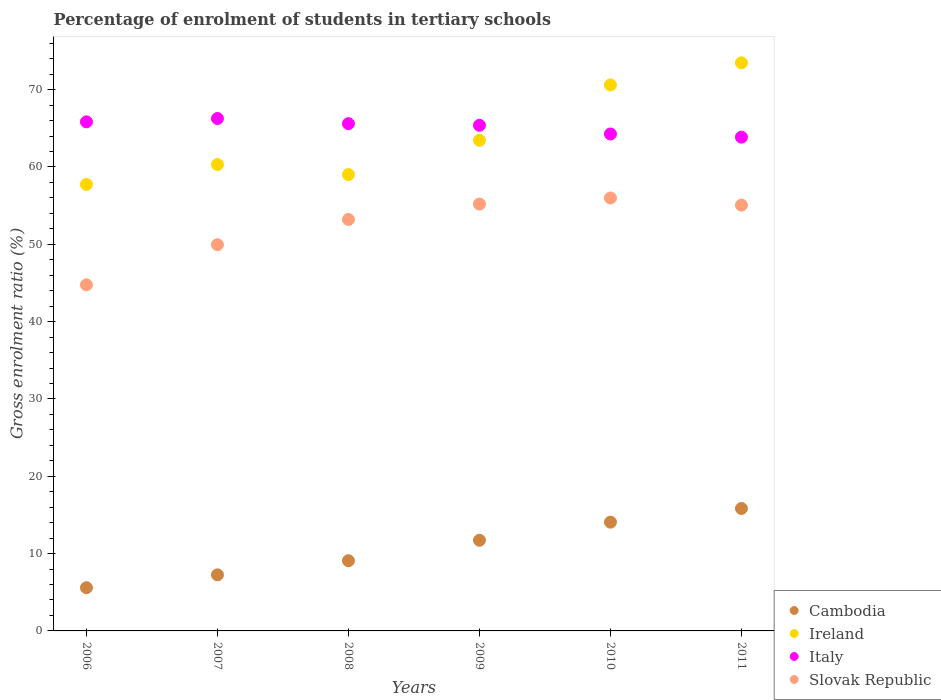What is the percentage of students enrolled in tertiary schools in Slovak Republic in 2008?
Offer a very short reply. 53.22. Across all years, what is the maximum percentage of students enrolled in tertiary schools in Ireland?
Your answer should be very brief. 73.47. Across all years, what is the minimum percentage of students enrolled in tertiary schools in Cambodia?
Provide a succinct answer. 5.59. In which year was the percentage of students enrolled in tertiary schools in Cambodia maximum?
Provide a short and direct response. 2011. What is the total percentage of students enrolled in tertiary schools in Italy in the graph?
Give a very brief answer. 391.22. What is the difference between the percentage of students enrolled in tertiary schools in Slovak Republic in 2007 and that in 2008?
Offer a very short reply. -3.27. What is the difference between the percentage of students enrolled in tertiary schools in Italy in 2008 and the percentage of students enrolled in tertiary schools in Slovak Republic in 2010?
Your response must be concise. 9.61. What is the average percentage of students enrolled in tertiary schools in Italy per year?
Make the answer very short. 65.2. In the year 2011, what is the difference between the percentage of students enrolled in tertiary schools in Cambodia and percentage of students enrolled in tertiary schools in Ireland?
Offer a terse response. -57.64. What is the ratio of the percentage of students enrolled in tertiary schools in Cambodia in 2007 to that in 2009?
Provide a succinct answer. 0.62. Is the percentage of students enrolled in tertiary schools in Slovak Republic in 2008 less than that in 2010?
Ensure brevity in your answer.  Yes. Is the difference between the percentage of students enrolled in tertiary schools in Cambodia in 2009 and 2011 greater than the difference between the percentage of students enrolled in tertiary schools in Ireland in 2009 and 2011?
Make the answer very short. Yes. What is the difference between the highest and the second highest percentage of students enrolled in tertiary schools in Slovak Republic?
Provide a succinct answer. 0.78. What is the difference between the highest and the lowest percentage of students enrolled in tertiary schools in Cambodia?
Provide a short and direct response. 10.24. In how many years, is the percentage of students enrolled in tertiary schools in Ireland greater than the average percentage of students enrolled in tertiary schools in Ireland taken over all years?
Your answer should be very brief. 2. Is the sum of the percentage of students enrolled in tertiary schools in Slovak Republic in 2008 and 2010 greater than the maximum percentage of students enrolled in tertiary schools in Italy across all years?
Give a very brief answer. Yes. Does the percentage of students enrolled in tertiary schools in Ireland monotonically increase over the years?
Make the answer very short. No. Is the percentage of students enrolled in tertiary schools in Ireland strictly less than the percentage of students enrolled in tertiary schools in Cambodia over the years?
Offer a terse response. No. How many dotlines are there?
Your answer should be compact. 4. How many years are there in the graph?
Offer a very short reply. 6. Are the values on the major ticks of Y-axis written in scientific E-notation?
Offer a terse response. No. What is the title of the graph?
Offer a very short reply. Percentage of enrolment of students in tertiary schools. What is the label or title of the X-axis?
Your response must be concise. Years. What is the label or title of the Y-axis?
Keep it short and to the point. Gross enrolment ratio (%). What is the Gross enrolment ratio (%) in Cambodia in 2006?
Offer a terse response. 5.59. What is the Gross enrolment ratio (%) of Ireland in 2006?
Provide a short and direct response. 57.75. What is the Gross enrolment ratio (%) of Italy in 2006?
Your answer should be very brief. 65.84. What is the Gross enrolment ratio (%) in Slovak Republic in 2006?
Offer a very short reply. 44.76. What is the Gross enrolment ratio (%) of Cambodia in 2007?
Ensure brevity in your answer.  7.25. What is the Gross enrolment ratio (%) in Ireland in 2007?
Offer a very short reply. 60.32. What is the Gross enrolment ratio (%) in Italy in 2007?
Keep it short and to the point. 66.27. What is the Gross enrolment ratio (%) in Slovak Republic in 2007?
Offer a very short reply. 49.95. What is the Gross enrolment ratio (%) of Cambodia in 2008?
Offer a terse response. 9.08. What is the Gross enrolment ratio (%) of Ireland in 2008?
Your answer should be compact. 59.02. What is the Gross enrolment ratio (%) in Italy in 2008?
Ensure brevity in your answer.  65.6. What is the Gross enrolment ratio (%) of Slovak Republic in 2008?
Provide a short and direct response. 53.22. What is the Gross enrolment ratio (%) of Cambodia in 2009?
Your answer should be compact. 11.72. What is the Gross enrolment ratio (%) in Ireland in 2009?
Ensure brevity in your answer.  63.45. What is the Gross enrolment ratio (%) in Italy in 2009?
Your answer should be compact. 65.39. What is the Gross enrolment ratio (%) in Slovak Republic in 2009?
Your response must be concise. 55.21. What is the Gross enrolment ratio (%) in Cambodia in 2010?
Offer a very short reply. 14.07. What is the Gross enrolment ratio (%) of Ireland in 2010?
Provide a succinct answer. 70.61. What is the Gross enrolment ratio (%) of Italy in 2010?
Offer a terse response. 64.27. What is the Gross enrolment ratio (%) in Slovak Republic in 2010?
Keep it short and to the point. 55.99. What is the Gross enrolment ratio (%) in Cambodia in 2011?
Offer a terse response. 15.83. What is the Gross enrolment ratio (%) in Ireland in 2011?
Offer a very short reply. 73.47. What is the Gross enrolment ratio (%) of Italy in 2011?
Make the answer very short. 63.86. What is the Gross enrolment ratio (%) in Slovak Republic in 2011?
Your response must be concise. 55.07. Across all years, what is the maximum Gross enrolment ratio (%) of Cambodia?
Make the answer very short. 15.83. Across all years, what is the maximum Gross enrolment ratio (%) of Ireland?
Your response must be concise. 73.47. Across all years, what is the maximum Gross enrolment ratio (%) of Italy?
Give a very brief answer. 66.27. Across all years, what is the maximum Gross enrolment ratio (%) in Slovak Republic?
Keep it short and to the point. 55.99. Across all years, what is the minimum Gross enrolment ratio (%) of Cambodia?
Offer a very short reply. 5.59. Across all years, what is the minimum Gross enrolment ratio (%) of Ireland?
Ensure brevity in your answer.  57.75. Across all years, what is the minimum Gross enrolment ratio (%) in Italy?
Provide a short and direct response. 63.86. Across all years, what is the minimum Gross enrolment ratio (%) of Slovak Republic?
Make the answer very short. 44.76. What is the total Gross enrolment ratio (%) in Cambodia in the graph?
Keep it short and to the point. 63.55. What is the total Gross enrolment ratio (%) of Ireland in the graph?
Your response must be concise. 384.61. What is the total Gross enrolment ratio (%) of Italy in the graph?
Your response must be concise. 391.22. What is the total Gross enrolment ratio (%) of Slovak Republic in the graph?
Keep it short and to the point. 314.19. What is the difference between the Gross enrolment ratio (%) of Cambodia in 2006 and that in 2007?
Ensure brevity in your answer.  -1.66. What is the difference between the Gross enrolment ratio (%) of Ireland in 2006 and that in 2007?
Make the answer very short. -2.58. What is the difference between the Gross enrolment ratio (%) of Italy in 2006 and that in 2007?
Provide a succinct answer. -0.43. What is the difference between the Gross enrolment ratio (%) of Slovak Republic in 2006 and that in 2007?
Make the answer very short. -5.19. What is the difference between the Gross enrolment ratio (%) of Cambodia in 2006 and that in 2008?
Provide a succinct answer. -3.49. What is the difference between the Gross enrolment ratio (%) in Ireland in 2006 and that in 2008?
Keep it short and to the point. -1.27. What is the difference between the Gross enrolment ratio (%) in Italy in 2006 and that in 2008?
Provide a succinct answer. 0.24. What is the difference between the Gross enrolment ratio (%) of Slovak Republic in 2006 and that in 2008?
Your answer should be very brief. -8.46. What is the difference between the Gross enrolment ratio (%) of Cambodia in 2006 and that in 2009?
Provide a short and direct response. -6.13. What is the difference between the Gross enrolment ratio (%) of Ireland in 2006 and that in 2009?
Ensure brevity in your answer.  -5.71. What is the difference between the Gross enrolment ratio (%) of Italy in 2006 and that in 2009?
Keep it short and to the point. 0.45. What is the difference between the Gross enrolment ratio (%) of Slovak Republic in 2006 and that in 2009?
Give a very brief answer. -10.45. What is the difference between the Gross enrolment ratio (%) of Cambodia in 2006 and that in 2010?
Make the answer very short. -8.48. What is the difference between the Gross enrolment ratio (%) in Ireland in 2006 and that in 2010?
Ensure brevity in your answer.  -12.86. What is the difference between the Gross enrolment ratio (%) of Italy in 2006 and that in 2010?
Give a very brief answer. 1.57. What is the difference between the Gross enrolment ratio (%) in Slovak Republic in 2006 and that in 2010?
Offer a terse response. -11.23. What is the difference between the Gross enrolment ratio (%) in Cambodia in 2006 and that in 2011?
Your response must be concise. -10.24. What is the difference between the Gross enrolment ratio (%) of Ireland in 2006 and that in 2011?
Offer a terse response. -15.73. What is the difference between the Gross enrolment ratio (%) in Italy in 2006 and that in 2011?
Keep it short and to the point. 1.98. What is the difference between the Gross enrolment ratio (%) of Slovak Republic in 2006 and that in 2011?
Your answer should be very brief. -10.31. What is the difference between the Gross enrolment ratio (%) of Cambodia in 2007 and that in 2008?
Your answer should be compact. -1.83. What is the difference between the Gross enrolment ratio (%) of Ireland in 2007 and that in 2008?
Provide a short and direct response. 1.3. What is the difference between the Gross enrolment ratio (%) of Italy in 2007 and that in 2008?
Keep it short and to the point. 0.66. What is the difference between the Gross enrolment ratio (%) of Slovak Republic in 2007 and that in 2008?
Offer a very short reply. -3.27. What is the difference between the Gross enrolment ratio (%) in Cambodia in 2007 and that in 2009?
Offer a terse response. -4.47. What is the difference between the Gross enrolment ratio (%) of Ireland in 2007 and that in 2009?
Offer a very short reply. -3.13. What is the difference between the Gross enrolment ratio (%) in Italy in 2007 and that in 2009?
Provide a short and direct response. 0.88. What is the difference between the Gross enrolment ratio (%) of Slovak Republic in 2007 and that in 2009?
Keep it short and to the point. -5.26. What is the difference between the Gross enrolment ratio (%) in Cambodia in 2007 and that in 2010?
Provide a succinct answer. -6.82. What is the difference between the Gross enrolment ratio (%) of Ireland in 2007 and that in 2010?
Make the answer very short. -10.29. What is the difference between the Gross enrolment ratio (%) in Italy in 2007 and that in 2010?
Make the answer very short. 2. What is the difference between the Gross enrolment ratio (%) of Slovak Republic in 2007 and that in 2010?
Offer a terse response. -6.04. What is the difference between the Gross enrolment ratio (%) in Cambodia in 2007 and that in 2011?
Ensure brevity in your answer.  -8.58. What is the difference between the Gross enrolment ratio (%) in Ireland in 2007 and that in 2011?
Offer a very short reply. -13.15. What is the difference between the Gross enrolment ratio (%) of Italy in 2007 and that in 2011?
Your answer should be very brief. 2.41. What is the difference between the Gross enrolment ratio (%) in Slovak Republic in 2007 and that in 2011?
Your answer should be compact. -5.13. What is the difference between the Gross enrolment ratio (%) in Cambodia in 2008 and that in 2009?
Provide a succinct answer. -2.64. What is the difference between the Gross enrolment ratio (%) in Ireland in 2008 and that in 2009?
Ensure brevity in your answer.  -4.43. What is the difference between the Gross enrolment ratio (%) of Italy in 2008 and that in 2009?
Provide a short and direct response. 0.21. What is the difference between the Gross enrolment ratio (%) of Slovak Republic in 2008 and that in 2009?
Provide a short and direct response. -1.99. What is the difference between the Gross enrolment ratio (%) of Cambodia in 2008 and that in 2010?
Give a very brief answer. -4.99. What is the difference between the Gross enrolment ratio (%) in Ireland in 2008 and that in 2010?
Offer a very short reply. -11.59. What is the difference between the Gross enrolment ratio (%) in Italy in 2008 and that in 2010?
Offer a terse response. 1.33. What is the difference between the Gross enrolment ratio (%) in Slovak Republic in 2008 and that in 2010?
Keep it short and to the point. -2.77. What is the difference between the Gross enrolment ratio (%) of Cambodia in 2008 and that in 2011?
Offer a terse response. -6.75. What is the difference between the Gross enrolment ratio (%) in Ireland in 2008 and that in 2011?
Give a very brief answer. -14.45. What is the difference between the Gross enrolment ratio (%) in Italy in 2008 and that in 2011?
Ensure brevity in your answer.  1.74. What is the difference between the Gross enrolment ratio (%) of Slovak Republic in 2008 and that in 2011?
Your response must be concise. -1.85. What is the difference between the Gross enrolment ratio (%) in Cambodia in 2009 and that in 2010?
Your response must be concise. -2.34. What is the difference between the Gross enrolment ratio (%) of Ireland in 2009 and that in 2010?
Make the answer very short. -7.15. What is the difference between the Gross enrolment ratio (%) in Italy in 2009 and that in 2010?
Ensure brevity in your answer.  1.12. What is the difference between the Gross enrolment ratio (%) in Slovak Republic in 2009 and that in 2010?
Offer a terse response. -0.78. What is the difference between the Gross enrolment ratio (%) of Cambodia in 2009 and that in 2011?
Give a very brief answer. -4.11. What is the difference between the Gross enrolment ratio (%) of Ireland in 2009 and that in 2011?
Offer a terse response. -10.02. What is the difference between the Gross enrolment ratio (%) of Italy in 2009 and that in 2011?
Offer a terse response. 1.53. What is the difference between the Gross enrolment ratio (%) in Slovak Republic in 2009 and that in 2011?
Keep it short and to the point. 0.13. What is the difference between the Gross enrolment ratio (%) of Cambodia in 2010 and that in 2011?
Offer a very short reply. -1.77. What is the difference between the Gross enrolment ratio (%) of Ireland in 2010 and that in 2011?
Offer a very short reply. -2.86. What is the difference between the Gross enrolment ratio (%) in Italy in 2010 and that in 2011?
Ensure brevity in your answer.  0.41. What is the difference between the Gross enrolment ratio (%) of Slovak Republic in 2010 and that in 2011?
Give a very brief answer. 0.92. What is the difference between the Gross enrolment ratio (%) in Cambodia in 2006 and the Gross enrolment ratio (%) in Ireland in 2007?
Your answer should be compact. -54.73. What is the difference between the Gross enrolment ratio (%) of Cambodia in 2006 and the Gross enrolment ratio (%) of Italy in 2007?
Provide a succinct answer. -60.67. What is the difference between the Gross enrolment ratio (%) of Cambodia in 2006 and the Gross enrolment ratio (%) of Slovak Republic in 2007?
Provide a succinct answer. -44.35. What is the difference between the Gross enrolment ratio (%) of Ireland in 2006 and the Gross enrolment ratio (%) of Italy in 2007?
Give a very brief answer. -8.52. What is the difference between the Gross enrolment ratio (%) in Ireland in 2006 and the Gross enrolment ratio (%) in Slovak Republic in 2007?
Your answer should be compact. 7.8. What is the difference between the Gross enrolment ratio (%) of Italy in 2006 and the Gross enrolment ratio (%) of Slovak Republic in 2007?
Your answer should be compact. 15.89. What is the difference between the Gross enrolment ratio (%) in Cambodia in 2006 and the Gross enrolment ratio (%) in Ireland in 2008?
Keep it short and to the point. -53.43. What is the difference between the Gross enrolment ratio (%) in Cambodia in 2006 and the Gross enrolment ratio (%) in Italy in 2008?
Your answer should be very brief. -60.01. What is the difference between the Gross enrolment ratio (%) of Cambodia in 2006 and the Gross enrolment ratio (%) of Slovak Republic in 2008?
Your answer should be very brief. -47.63. What is the difference between the Gross enrolment ratio (%) of Ireland in 2006 and the Gross enrolment ratio (%) of Italy in 2008?
Offer a very short reply. -7.86. What is the difference between the Gross enrolment ratio (%) of Ireland in 2006 and the Gross enrolment ratio (%) of Slovak Republic in 2008?
Provide a short and direct response. 4.53. What is the difference between the Gross enrolment ratio (%) in Italy in 2006 and the Gross enrolment ratio (%) in Slovak Republic in 2008?
Offer a terse response. 12.62. What is the difference between the Gross enrolment ratio (%) of Cambodia in 2006 and the Gross enrolment ratio (%) of Ireland in 2009?
Your answer should be very brief. -57.86. What is the difference between the Gross enrolment ratio (%) in Cambodia in 2006 and the Gross enrolment ratio (%) in Italy in 2009?
Provide a succinct answer. -59.8. What is the difference between the Gross enrolment ratio (%) in Cambodia in 2006 and the Gross enrolment ratio (%) in Slovak Republic in 2009?
Keep it short and to the point. -49.61. What is the difference between the Gross enrolment ratio (%) of Ireland in 2006 and the Gross enrolment ratio (%) of Italy in 2009?
Provide a succinct answer. -7.64. What is the difference between the Gross enrolment ratio (%) of Ireland in 2006 and the Gross enrolment ratio (%) of Slovak Republic in 2009?
Ensure brevity in your answer.  2.54. What is the difference between the Gross enrolment ratio (%) of Italy in 2006 and the Gross enrolment ratio (%) of Slovak Republic in 2009?
Ensure brevity in your answer.  10.63. What is the difference between the Gross enrolment ratio (%) of Cambodia in 2006 and the Gross enrolment ratio (%) of Ireland in 2010?
Give a very brief answer. -65.01. What is the difference between the Gross enrolment ratio (%) in Cambodia in 2006 and the Gross enrolment ratio (%) in Italy in 2010?
Keep it short and to the point. -58.68. What is the difference between the Gross enrolment ratio (%) of Cambodia in 2006 and the Gross enrolment ratio (%) of Slovak Republic in 2010?
Provide a succinct answer. -50.4. What is the difference between the Gross enrolment ratio (%) in Ireland in 2006 and the Gross enrolment ratio (%) in Italy in 2010?
Ensure brevity in your answer.  -6.52. What is the difference between the Gross enrolment ratio (%) of Ireland in 2006 and the Gross enrolment ratio (%) of Slovak Republic in 2010?
Your answer should be compact. 1.76. What is the difference between the Gross enrolment ratio (%) in Italy in 2006 and the Gross enrolment ratio (%) in Slovak Republic in 2010?
Provide a succinct answer. 9.85. What is the difference between the Gross enrolment ratio (%) of Cambodia in 2006 and the Gross enrolment ratio (%) of Ireland in 2011?
Offer a very short reply. -67.88. What is the difference between the Gross enrolment ratio (%) in Cambodia in 2006 and the Gross enrolment ratio (%) in Italy in 2011?
Provide a succinct answer. -58.27. What is the difference between the Gross enrolment ratio (%) of Cambodia in 2006 and the Gross enrolment ratio (%) of Slovak Republic in 2011?
Keep it short and to the point. -49.48. What is the difference between the Gross enrolment ratio (%) of Ireland in 2006 and the Gross enrolment ratio (%) of Italy in 2011?
Provide a short and direct response. -6.11. What is the difference between the Gross enrolment ratio (%) in Ireland in 2006 and the Gross enrolment ratio (%) in Slovak Republic in 2011?
Offer a terse response. 2.67. What is the difference between the Gross enrolment ratio (%) in Italy in 2006 and the Gross enrolment ratio (%) in Slovak Republic in 2011?
Your answer should be compact. 10.77. What is the difference between the Gross enrolment ratio (%) in Cambodia in 2007 and the Gross enrolment ratio (%) in Ireland in 2008?
Your answer should be very brief. -51.77. What is the difference between the Gross enrolment ratio (%) in Cambodia in 2007 and the Gross enrolment ratio (%) in Italy in 2008?
Provide a short and direct response. -58.35. What is the difference between the Gross enrolment ratio (%) in Cambodia in 2007 and the Gross enrolment ratio (%) in Slovak Republic in 2008?
Offer a very short reply. -45.97. What is the difference between the Gross enrolment ratio (%) in Ireland in 2007 and the Gross enrolment ratio (%) in Italy in 2008?
Provide a short and direct response. -5.28. What is the difference between the Gross enrolment ratio (%) in Ireland in 2007 and the Gross enrolment ratio (%) in Slovak Republic in 2008?
Ensure brevity in your answer.  7.1. What is the difference between the Gross enrolment ratio (%) in Italy in 2007 and the Gross enrolment ratio (%) in Slovak Republic in 2008?
Give a very brief answer. 13.05. What is the difference between the Gross enrolment ratio (%) in Cambodia in 2007 and the Gross enrolment ratio (%) in Ireland in 2009?
Your answer should be compact. -56.2. What is the difference between the Gross enrolment ratio (%) of Cambodia in 2007 and the Gross enrolment ratio (%) of Italy in 2009?
Keep it short and to the point. -58.14. What is the difference between the Gross enrolment ratio (%) in Cambodia in 2007 and the Gross enrolment ratio (%) in Slovak Republic in 2009?
Your answer should be compact. -47.95. What is the difference between the Gross enrolment ratio (%) in Ireland in 2007 and the Gross enrolment ratio (%) in Italy in 2009?
Offer a terse response. -5.07. What is the difference between the Gross enrolment ratio (%) in Ireland in 2007 and the Gross enrolment ratio (%) in Slovak Republic in 2009?
Offer a terse response. 5.11. What is the difference between the Gross enrolment ratio (%) in Italy in 2007 and the Gross enrolment ratio (%) in Slovak Republic in 2009?
Your response must be concise. 11.06. What is the difference between the Gross enrolment ratio (%) of Cambodia in 2007 and the Gross enrolment ratio (%) of Ireland in 2010?
Offer a very short reply. -63.36. What is the difference between the Gross enrolment ratio (%) of Cambodia in 2007 and the Gross enrolment ratio (%) of Italy in 2010?
Provide a short and direct response. -57.02. What is the difference between the Gross enrolment ratio (%) of Cambodia in 2007 and the Gross enrolment ratio (%) of Slovak Republic in 2010?
Your answer should be very brief. -48.74. What is the difference between the Gross enrolment ratio (%) of Ireland in 2007 and the Gross enrolment ratio (%) of Italy in 2010?
Make the answer very short. -3.95. What is the difference between the Gross enrolment ratio (%) of Ireland in 2007 and the Gross enrolment ratio (%) of Slovak Republic in 2010?
Your response must be concise. 4.33. What is the difference between the Gross enrolment ratio (%) of Italy in 2007 and the Gross enrolment ratio (%) of Slovak Republic in 2010?
Your answer should be compact. 10.28. What is the difference between the Gross enrolment ratio (%) of Cambodia in 2007 and the Gross enrolment ratio (%) of Ireland in 2011?
Make the answer very short. -66.22. What is the difference between the Gross enrolment ratio (%) in Cambodia in 2007 and the Gross enrolment ratio (%) in Italy in 2011?
Your response must be concise. -56.61. What is the difference between the Gross enrolment ratio (%) in Cambodia in 2007 and the Gross enrolment ratio (%) in Slovak Republic in 2011?
Offer a terse response. -47.82. What is the difference between the Gross enrolment ratio (%) in Ireland in 2007 and the Gross enrolment ratio (%) in Italy in 2011?
Keep it short and to the point. -3.54. What is the difference between the Gross enrolment ratio (%) of Ireland in 2007 and the Gross enrolment ratio (%) of Slovak Republic in 2011?
Keep it short and to the point. 5.25. What is the difference between the Gross enrolment ratio (%) in Italy in 2007 and the Gross enrolment ratio (%) in Slovak Republic in 2011?
Ensure brevity in your answer.  11.19. What is the difference between the Gross enrolment ratio (%) in Cambodia in 2008 and the Gross enrolment ratio (%) in Ireland in 2009?
Provide a short and direct response. -54.37. What is the difference between the Gross enrolment ratio (%) in Cambodia in 2008 and the Gross enrolment ratio (%) in Italy in 2009?
Keep it short and to the point. -56.31. What is the difference between the Gross enrolment ratio (%) in Cambodia in 2008 and the Gross enrolment ratio (%) in Slovak Republic in 2009?
Provide a short and direct response. -46.13. What is the difference between the Gross enrolment ratio (%) in Ireland in 2008 and the Gross enrolment ratio (%) in Italy in 2009?
Make the answer very short. -6.37. What is the difference between the Gross enrolment ratio (%) of Ireland in 2008 and the Gross enrolment ratio (%) of Slovak Republic in 2009?
Your answer should be compact. 3.81. What is the difference between the Gross enrolment ratio (%) of Italy in 2008 and the Gross enrolment ratio (%) of Slovak Republic in 2009?
Give a very brief answer. 10.4. What is the difference between the Gross enrolment ratio (%) of Cambodia in 2008 and the Gross enrolment ratio (%) of Ireland in 2010?
Provide a succinct answer. -61.53. What is the difference between the Gross enrolment ratio (%) in Cambodia in 2008 and the Gross enrolment ratio (%) in Italy in 2010?
Make the answer very short. -55.19. What is the difference between the Gross enrolment ratio (%) of Cambodia in 2008 and the Gross enrolment ratio (%) of Slovak Republic in 2010?
Offer a very short reply. -46.91. What is the difference between the Gross enrolment ratio (%) in Ireland in 2008 and the Gross enrolment ratio (%) in Italy in 2010?
Your response must be concise. -5.25. What is the difference between the Gross enrolment ratio (%) in Ireland in 2008 and the Gross enrolment ratio (%) in Slovak Republic in 2010?
Offer a very short reply. 3.03. What is the difference between the Gross enrolment ratio (%) of Italy in 2008 and the Gross enrolment ratio (%) of Slovak Republic in 2010?
Offer a terse response. 9.61. What is the difference between the Gross enrolment ratio (%) of Cambodia in 2008 and the Gross enrolment ratio (%) of Ireland in 2011?
Keep it short and to the point. -64.39. What is the difference between the Gross enrolment ratio (%) in Cambodia in 2008 and the Gross enrolment ratio (%) in Italy in 2011?
Ensure brevity in your answer.  -54.78. What is the difference between the Gross enrolment ratio (%) of Cambodia in 2008 and the Gross enrolment ratio (%) of Slovak Republic in 2011?
Provide a short and direct response. -45.99. What is the difference between the Gross enrolment ratio (%) of Ireland in 2008 and the Gross enrolment ratio (%) of Italy in 2011?
Ensure brevity in your answer.  -4.84. What is the difference between the Gross enrolment ratio (%) in Ireland in 2008 and the Gross enrolment ratio (%) in Slovak Republic in 2011?
Ensure brevity in your answer.  3.95. What is the difference between the Gross enrolment ratio (%) of Italy in 2008 and the Gross enrolment ratio (%) of Slovak Republic in 2011?
Your answer should be very brief. 10.53. What is the difference between the Gross enrolment ratio (%) in Cambodia in 2009 and the Gross enrolment ratio (%) in Ireland in 2010?
Make the answer very short. -58.88. What is the difference between the Gross enrolment ratio (%) of Cambodia in 2009 and the Gross enrolment ratio (%) of Italy in 2010?
Offer a terse response. -52.55. What is the difference between the Gross enrolment ratio (%) in Cambodia in 2009 and the Gross enrolment ratio (%) in Slovak Republic in 2010?
Make the answer very short. -44.27. What is the difference between the Gross enrolment ratio (%) in Ireland in 2009 and the Gross enrolment ratio (%) in Italy in 2010?
Give a very brief answer. -0.82. What is the difference between the Gross enrolment ratio (%) in Ireland in 2009 and the Gross enrolment ratio (%) in Slovak Republic in 2010?
Your answer should be very brief. 7.46. What is the difference between the Gross enrolment ratio (%) of Italy in 2009 and the Gross enrolment ratio (%) of Slovak Republic in 2010?
Your answer should be very brief. 9.4. What is the difference between the Gross enrolment ratio (%) of Cambodia in 2009 and the Gross enrolment ratio (%) of Ireland in 2011?
Provide a short and direct response. -61.75. What is the difference between the Gross enrolment ratio (%) of Cambodia in 2009 and the Gross enrolment ratio (%) of Italy in 2011?
Ensure brevity in your answer.  -52.13. What is the difference between the Gross enrolment ratio (%) in Cambodia in 2009 and the Gross enrolment ratio (%) in Slovak Republic in 2011?
Provide a short and direct response. -43.35. What is the difference between the Gross enrolment ratio (%) of Ireland in 2009 and the Gross enrolment ratio (%) of Italy in 2011?
Ensure brevity in your answer.  -0.41. What is the difference between the Gross enrolment ratio (%) in Ireland in 2009 and the Gross enrolment ratio (%) in Slovak Republic in 2011?
Provide a succinct answer. 8.38. What is the difference between the Gross enrolment ratio (%) in Italy in 2009 and the Gross enrolment ratio (%) in Slovak Republic in 2011?
Your response must be concise. 10.32. What is the difference between the Gross enrolment ratio (%) of Cambodia in 2010 and the Gross enrolment ratio (%) of Ireland in 2011?
Your response must be concise. -59.4. What is the difference between the Gross enrolment ratio (%) in Cambodia in 2010 and the Gross enrolment ratio (%) in Italy in 2011?
Make the answer very short. -49.79. What is the difference between the Gross enrolment ratio (%) in Cambodia in 2010 and the Gross enrolment ratio (%) in Slovak Republic in 2011?
Your answer should be very brief. -41. What is the difference between the Gross enrolment ratio (%) in Ireland in 2010 and the Gross enrolment ratio (%) in Italy in 2011?
Your answer should be very brief. 6.75. What is the difference between the Gross enrolment ratio (%) in Ireland in 2010 and the Gross enrolment ratio (%) in Slovak Republic in 2011?
Offer a terse response. 15.53. What is the difference between the Gross enrolment ratio (%) of Italy in 2010 and the Gross enrolment ratio (%) of Slovak Republic in 2011?
Ensure brevity in your answer.  9.2. What is the average Gross enrolment ratio (%) of Cambodia per year?
Your answer should be very brief. 10.59. What is the average Gross enrolment ratio (%) of Ireland per year?
Offer a terse response. 64.1. What is the average Gross enrolment ratio (%) in Italy per year?
Provide a succinct answer. 65.2. What is the average Gross enrolment ratio (%) of Slovak Republic per year?
Keep it short and to the point. 52.36. In the year 2006, what is the difference between the Gross enrolment ratio (%) of Cambodia and Gross enrolment ratio (%) of Ireland?
Keep it short and to the point. -52.15. In the year 2006, what is the difference between the Gross enrolment ratio (%) in Cambodia and Gross enrolment ratio (%) in Italy?
Make the answer very short. -60.25. In the year 2006, what is the difference between the Gross enrolment ratio (%) in Cambodia and Gross enrolment ratio (%) in Slovak Republic?
Your answer should be compact. -39.17. In the year 2006, what is the difference between the Gross enrolment ratio (%) of Ireland and Gross enrolment ratio (%) of Italy?
Give a very brief answer. -8.09. In the year 2006, what is the difference between the Gross enrolment ratio (%) of Ireland and Gross enrolment ratio (%) of Slovak Republic?
Your answer should be compact. 12.99. In the year 2006, what is the difference between the Gross enrolment ratio (%) in Italy and Gross enrolment ratio (%) in Slovak Republic?
Ensure brevity in your answer.  21.08. In the year 2007, what is the difference between the Gross enrolment ratio (%) of Cambodia and Gross enrolment ratio (%) of Ireland?
Your answer should be very brief. -53.07. In the year 2007, what is the difference between the Gross enrolment ratio (%) of Cambodia and Gross enrolment ratio (%) of Italy?
Your answer should be very brief. -59.02. In the year 2007, what is the difference between the Gross enrolment ratio (%) of Cambodia and Gross enrolment ratio (%) of Slovak Republic?
Your answer should be very brief. -42.7. In the year 2007, what is the difference between the Gross enrolment ratio (%) of Ireland and Gross enrolment ratio (%) of Italy?
Your answer should be very brief. -5.95. In the year 2007, what is the difference between the Gross enrolment ratio (%) in Ireland and Gross enrolment ratio (%) in Slovak Republic?
Make the answer very short. 10.37. In the year 2007, what is the difference between the Gross enrolment ratio (%) in Italy and Gross enrolment ratio (%) in Slovak Republic?
Keep it short and to the point. 16.32. In the year 2008, what is the difference between the Gross enrolment ratio (%) in Cambodia and Gross enrolment ratio (%) in Ireland?
Your answer should be compact. -49.94. In the year 2008, what is the difference between the Gross enrolment ratio (%) in Cambodia and Gross enrolment ratio (%) in Italy?
Your answer should be compact. -56.52. In the year 2008, what is the difference between the Gross enrolment ratio (%) of Cambodia and Gross enrolment ratio (%) of Slovak Republic?
Your answer should be very brief. -44.14. In the year 2008, what is the difference between the Gross enrolment ratio (%) in Ireland and Gross enrolment ratio (%) in Italy?
Your answer should be compact. -6.58. In the year 2008, what is the difference between the Gross enrolment ratio (%) of Ireland and Gross enrolment ratio (%) of Slovak Republic?
Provide a succinct answer. 5.8. In the year 2008, what is the difference between the Gross enrolment ratio (%) in Italy and Gross enrolment ratio (%) in Slovak Republic?
Offer a terse response. 12.38. In the year 2009, what is the difference between the Gross enrolment ratio (%) in Cambodia and Gross enrolment ratio (%) in Ireland?
Offer a terse response. -51.73. In the year 2009, what is the difference between the Gross enrolment ratio (%) in Cambodia and Gross enrolment ratio (%) in Italy?
Provide a succinct answer. -53.67. In the year 2009, what is the difference between the Gross enrolment ratio (%) in Cambodia and Gross enrolment ratio (%) in Slovak Republic?
Make the answer very short. -43.48. In the year 2009, what is the difference between the Gross enrolment ratio (%) of Ireland and Gross enrolment ratio (%) of Italy?
Keep it short and to the point. -1.94. In the year 2009, what is the difference between the Gross enrolment ratio (%) in Ireland and Gross enrolment ratio (%) in Slovak Republic?
Provide a short and direct response. 8.25. In the year 2009, what is the difference between the Gross enrolment ratio (%) of Italy and Gross enrolment ratio (%) of Slovak Republic?
Your answer should be compact. 10.18. In the year 2010, what is the difference between the Gross enrolment ratio (%) in Cambodia and Gross enrolment ratio (%) in Ireland?
Offer a very short reply. -56.54. In the year 2010, what is the difference between the Gross enrolment ratio (%) of Cambodia and Gross enrolment ratio (%) of Italy?
Provide a succinct answer. -50.2. In the year 2010, what is the difference between the Gross enrolment ratio (%) in Cambodia and Gross enrolment ratio (%) in Slovak Republic?
Keep it short and to the point. -41.92. In the year 2010, what is the difference between the Gross enrolment ratio (%) in Ireland and Gross enrolment ratio (%) in Italy?
Provide a succinct answer. 6.34. In the year 2010, what is the difference between the Gross enrolment ratio (%) in Ireland and Gross enrolment ratio (%) in Slovak Republic?
Give a very brief answer. 14.62. In the year 2010, what is the difference between the Gross enrolment ratio (%) of Italy and Gross enrolment ratio (%) of Slovak Republic?
Offer a very short reply. 8.28. In the year 2011, what is the difference between the Gross enrolment ratio (%) in Cambodia and Gross enrolment ratio (%) in Ireland?
Provide a succinct answer. -57.64. In the year 2011, what is the difference between the Gross enrolment ratio (%) of Cambodia and Gross enrolment ratio (%) of Italy?
Your answer should be compact. -48.02. In the year 2011, what is the difference between the Gross enrolment ratio (%) in Cambodia and Gross enrolment ratio (%) in Slovak Republic?
Ensure brevity in your answer.  -39.24. In the year 2011, what is the difference between the Gross enrolment ratio (%) of Ireland and Gross enrolment ratio (%) of Italy?
Your answer should be very brief. 9.61. In the year 2011, what is the difference between the Gross enrolment ratio (%) in Ireland and Gross enrolment ratio (%) in Slovak Republic?
Your answer should be very brief. 18.4. In the year 2011, what is the difference between the Gross enrolment ratio (%) of Italy and Gross enrolment ratio (%) of Slovak Republic?
Your answer should be very brief. 8.79. What is the ratio of the Gross enrolment ratio (%) of Cambodia in 2006 to that in 2007?
Provide a succinct answer. 0.77. What is the ratio of the Gross enrolment ratio (%) in Ireland in 2006 to that in 2007?
Offer a very short reply. 0.96. What is the ratio of the Gross enrolment ratio (%) in Slovak Republic in 2006 to that in 2007?
Your answer should be compact. 0.9. What is the ratio of the Gross enrolment ratio (%) of Cambodia in 2006 to that in 2008?
Ensure brevity in your answer.  0.62. What is the ratio of the Gross enrolment ratio (%) of Ireland in 2006 to that in 2008?
Ensure brevity in your answer.  0.98. What is the ratio of the Gross enrolment ratio (%) of Slovak Republic in 2006 to that in 2008?
Ensure brevity in your answer.  0.84. What is the ratio of the Gross enrolment ratio (%) in Cambodia in 2006 to that in 2009?
Your answer should be compact. 0.48. What is the ratio of the Gross enrolment ratio (%) in Ireland in 2006 to that in 2009?
Your response must be concise. 0.91. What is the ratio of the Gross enrolment ratio (%) of Italy in 2006 to that in 2009?
Provide a succinct answer. 1.01. What is the ratio of the Gross enrolment ratio (%) in Slovak Republic in 2006 to that in 2009?
Offer a terse response. 0.81. What is the ratio of the Gross enrolment ratio (%) in Cambodia in 2006 to that in 2010?
Give a very brief answer. 0.4. What is the ratio of the Gross enrolment ratio (%) in Ireland in 2006 to that in 2010?
Your answer should be compact. 0.82. What is the ratio of the Gross enrolment ratio (%) of Italy in 2006 to that in 2010?
Offer a very short reply. 1.02. What is the ratio of the Gross enrolment ratio (%) in Slovak Republic in 2006 to that in 2010?
Make the answer very short. 0.8. What is the ratio of the Gross enrolment ratio (%) in Cambodia in 2006 to that in 2011?
Offer a terse response. 0.35. What is the ratio of the Gross enrolment ratio (%) of Ireland in 2006 to that in 2011?
Your answer should be very brief. 0.79. What is the ratio of the Gross enrolment ratio (%) in Italy in 2006 to that in 2011?
Your answer should be compact. 1.03. What is the ratio of the Gross enrolment ratio (%) in Slovak Republic in 2006 to that in 2011?
Give a very brief answer. 0.81. What is the ratio of the Gross enrolment ratio (%) of Cambodia in 2007 to that in 2008?
Make the answer very short. 0.8. What is the ratio of the Gross enrolment ratio (%) in Ireland in 2007 to that in 2008?
Provide a short and direct response. 1.02. What is the ratio of the Gross enrolment ratio (%) of Slovak Republic in 2007 to that in 2008?
Keep it short and to the point. 0.94. What is the ratio of the Gross enrolment ratio (%) in Cambodia in 2007 to that in 2009?
Your answer should be very brief. 0.62. What is the ratio of the Gross enrolment ratio (%) in Ireland in 2007 to that in 2009?
Give a very brief answer. 0.95. What is the ratio of the Gross enrolment ratio (%) of Italy in 2007 to that in 2009?
Give a very brief answer. 1.01. What is the ratio of the Gross enrolment ratio (%) in Slovak Republic in 2007 to that in 2009?
Offer a terse response. 0.9. What is the ratio of the Gross enrolment ratio (%) of Cambodia in 2007 to that in 2010?
Provide a succinct answer. 0.52. What is the ratio of the Gross enrolment ratio (%) in Ireland in 2007 to that in 2010?
Keep it short and to the point. 0.85. What is the ratio of the Gross enrolment ratio (%) in Italy in 2007 to that in 2010?
Keep it short and to the point. 1.03. What is the ratio of the Gross enrolment ratio (%) of Slovak Republic in 2007 to that in 2010?
Provide a short and direct response. 0.89. What is the ratio of the Gross enrolment ratio (%) of Cambodia in 2007 to that in 2011?
Offer a terse response. 0.46. What is the ratio of the Gross enrolment ratio (%) of Ireland in 2007 to that in 2011?
Keep it short and to the point. 0.82. What is the ratio of the Gross enrolment ratio (%) in Italy in 2007 to that in 2011?
Give a very brief answer. 1.04. What is the ratio of the Gross enrolment ratio (%) in Slovak Republic in 2007 to that in 2011?
Keep it short and to the point. 0.91. What is the ratio of the Gross enrolment ratio (%) of Cambodia in 2008 to that in 2009?
Your answer should be compact. 0.77. What is the ratio of the Gross enrolment ratio (%) of Ireland in 2008 to that in 2009?
Keep it short and to the point. 0.93. What is the ratio of the Gross enrolment ratio (%) of Italy in 2008 to that in 2009?
Ensure brevity in your answer.  1. What is the ratio of the Gross enrolment ratio (%) of Cambodia in 2008 to that in 2010?
Offer a very short reply. 0.65. What is the ratio of the Gross enrolment ratio (%) of Ireland in 2008 to that in 2010?
Make the answer very short. 0.84. What is the ratio of the Gross enrolment ratio (%) in Italy in 2008 to that in 2010?
Provide a short and direct response. 1.02. What is the ratio of the Gross enrolment ratio (%) in Slovak Republic in 2008 to that in 2010?
Offer a terse response. 0.95. What is the ratio of the Gross enrolment ratio (%) in Cambodia in 2008 to that in 2011?
Your answer should be compact. 0.57. What is the ratio of the Gross enrolment ratio (%) of Ireland in 2008 to that in 2011?
Offer a terse response. 0.8. What is the ratio of the Gross enrolment ratio (%) of Italy in 2008 to that in 2011?
Your answer should be very brief. 1.03. What is the ratio of the Gross enrolment ratio (%) of Slovak Republic in 2008 to that in 2011?
Your answer should be very brief. 0.97. What is the ratio of the Gross enrolment ratio (%) in Cambodia in 2009 to that in 2010?
Give a very brief answer. 0.83. What is the ratio of the Gross enrolment ratio (%) of Ireland in 2009 to that in 2010?
Your answer should be very brief. 0.9. What is the ratio of the Gross enrolment ratio (%) of Italy in 2009 to that in 2010?
Keep it short and to the point. 1.02. What is the ratio of the Gross enrolment ratio (%) of Slovak Republic in 2009 to that in 2010?
Your response must be concise. 0.99. What is the ratio of the Gross enrolment ratio (%) of Cambodia in 2009 to that in 2011?
Make the answer very short. 0.74. What is the ratio of the Gross enrolment ratio (%) in Ireland in 2009 to that in 2011?
Make the answer very short. 0.86. What is the ratio of the Gross enrolment ratio (%) in Cambodia in 2010 to that in 2011?
Provide a succinct answer. 0.89. What is the ratio of the Gross enrolment ratio (%) of Ireland in 2010 to that in 2011?
Ensure brevity in your answer.  0.96. What is the ratio of the Gross enrolment ratio (%) of Italy in 2010 to that in 2011?
Offer a very short reply. 1.01. What is the ratio of the Gross enrolment ratio (%) in Slovak Republic in 2010 to that in 2011?
Offer a very short reply. 1.02. What is the difference between the highest and the second highest Gross enrolment ratio (%) of Cambodia?
Provide a short and direct response. 1.77. What is the difference between the highest and the second highest Gross enrolment ratio (%) of Ireland?
Make the answer very short. 2.86. What is the difference between the highest and the second highest Gross enrolment ratio (%) in Italy?
Give a very brief answer. 0.43. What is the difference between the highest and the second highest Gross enrolment ratio (%) in Slovak Republic?
Make the answer very short. 0.78. What is the difference between the highest and the lowest Gross enrolment ratio (%) in Cambodia?
Your answer should be very brief. 10.24. What is the difference between the highest and the lowest Gross enrolment ratio (%) in Ireland?
Give a very brief answer. 15.73. What is the difference between the highest and the lowest Gross enrolment ratio (%) in Italy?
Make the answer very short. 2.41. What is the difference between the highest and the lowest Gross enrolment ratio (%) in Slovak Republic?
Provide a succinct answer. 11.23. 